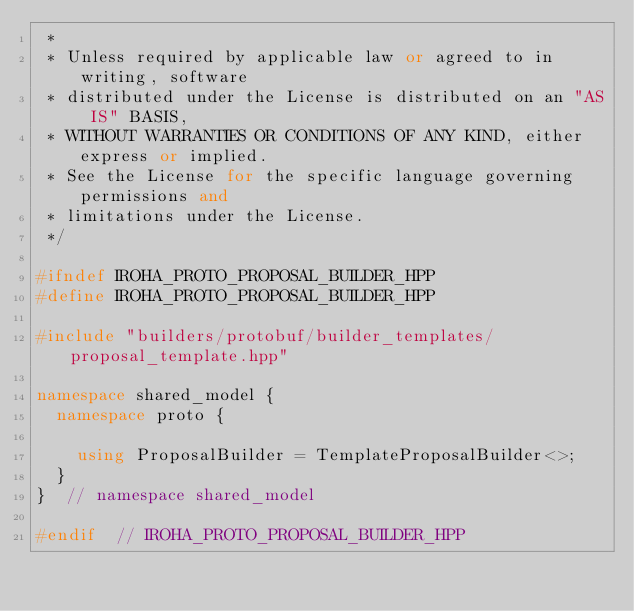Convert code to text. <code><loc_0><loc_0><loc_500><loc_500><_C++_> *
 * Unless required by applicable law or agreed to in writing, software
 * distributed under the License is distributed on an "AS IS" BASIS,
 * WITHOUT WARRANTIES OR CONDITIONS OF ANY KIND, either express or implied.
 * See the License for the specific language governing permissions and
 * limitations under the License.
 */

#ifndef IROHA_PROTO_PROPOSAL_BUILDER_HPP
#define IROHA_PROTO_PROPOSAL_BUILDER_HPP

#include "builders/protobuf/builder_templates/proposal_template.hpp"

namespace shared_model {
  namespace proto {

    using ProposalBuilder = TemplateProposalBuilder<>;
  }
}  // namespace shared_model

#endif  // IROHA_PROTO_PROPOSAL_BUILDER_HPP
</code> 